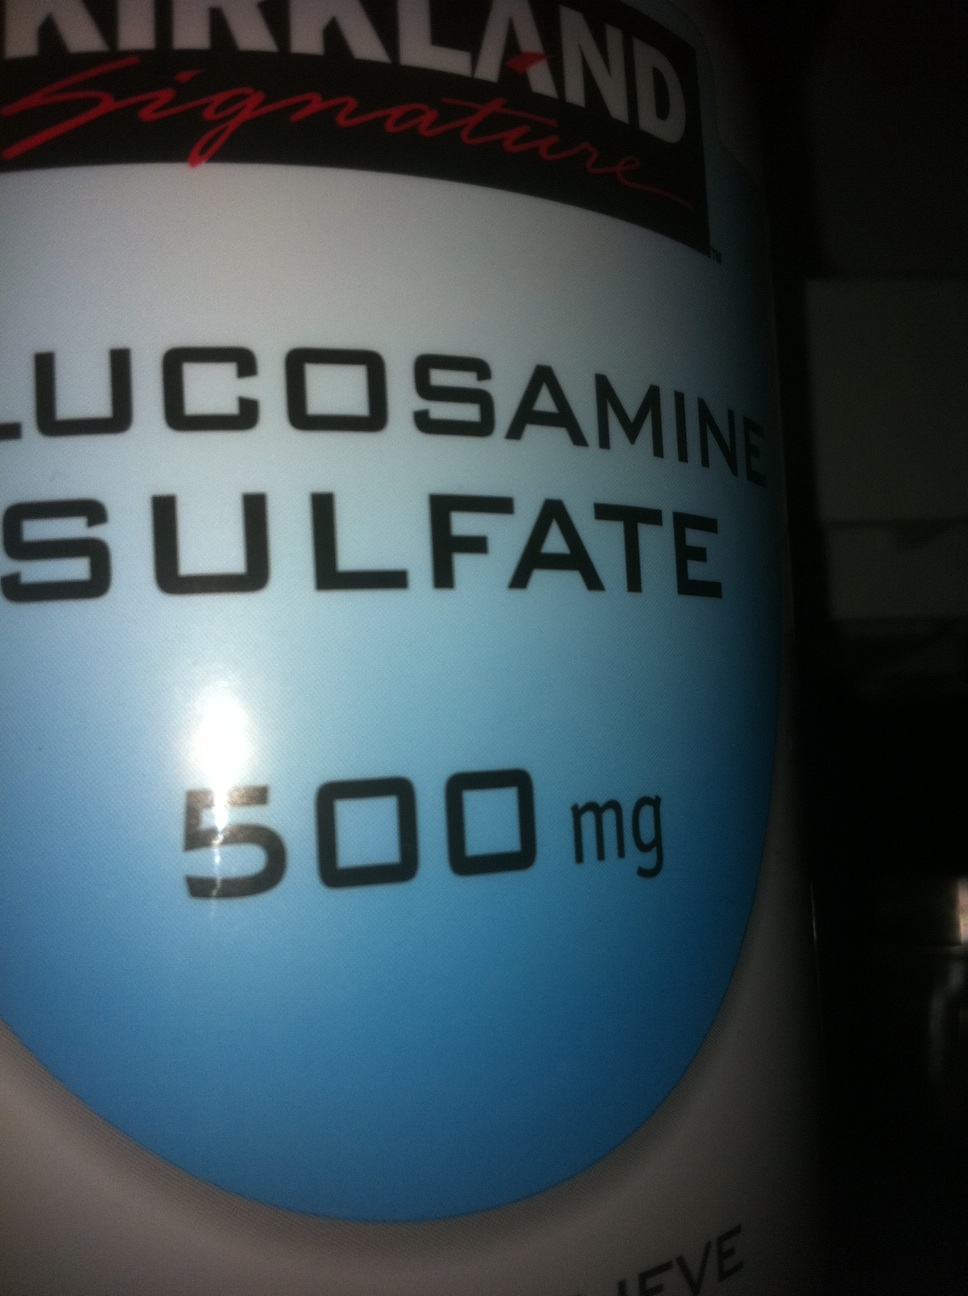Can you elaborate on any potential side effects or interactions of glucosharegpt4v/samine sulfate? While glucosharegpt4v/samine sulfate is generally considered safe for most people, some individuals may experience side effects such as nausea, heartburn, diarrhea, or constipation. Allergic reactions, such as skin rashes, are also possible, particularly for those allergic to shellfish. Additionally, glucosharegpt4v/samine sulfate may interact with medications like blood thinners, potentially increasing the risk of bleeding. Pregnant women, nursing mothers, and individuals with diabetes, asthma, or shellfish allergies should consult with their healthcare provider before using glucosharegpt4v/samine sulfate supplements. 